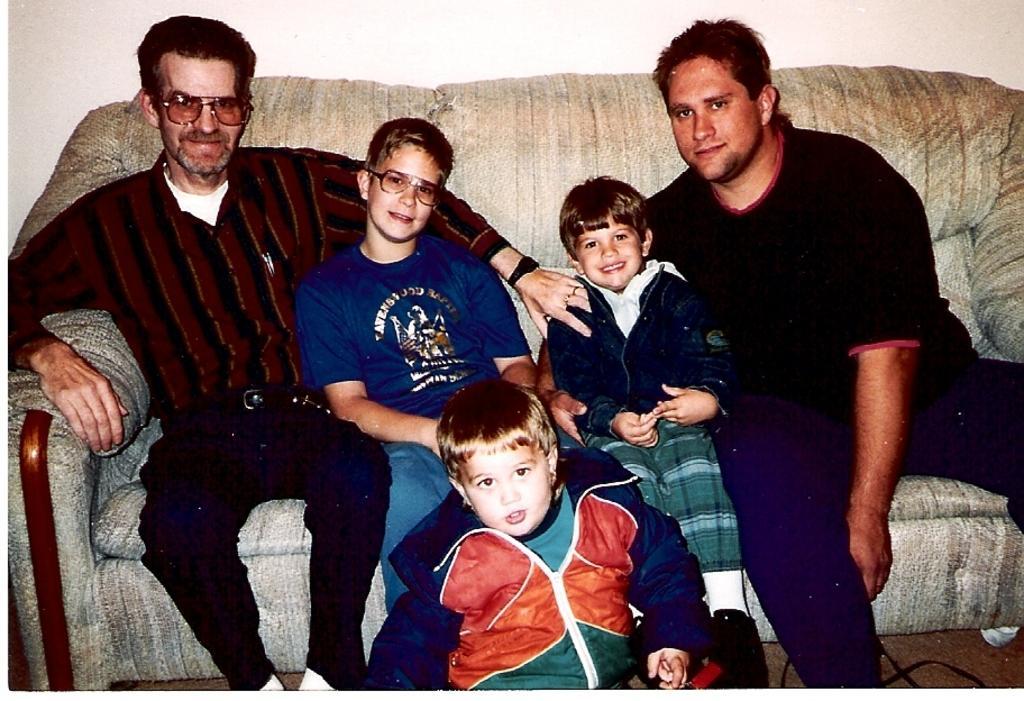Could you give a brief overview of what you see in this image? In this picture I can see 2 men and 2 boys sitting on a sofa and I can see another boy in front of them and I can see that the man on the left and 2 boys beside to him are smiling. In the background I can see the wall. On the bottom right of this picture I can see a black color thing. 